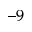Convert formula to latex. <formula><loc_0><loc_0><loc_500><loc_500>^ { - 9 }</formula> 